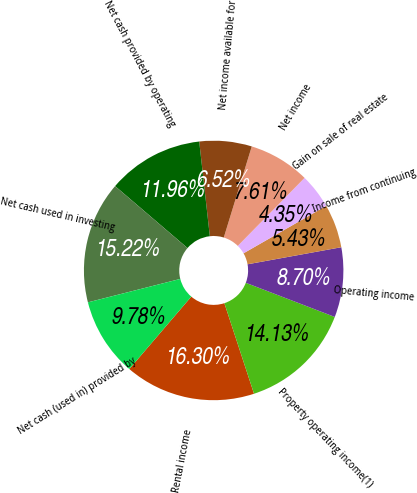Convert chart to OTSL. <chart><loc_0><loc_0><loc_500><loc_500><pie_chart><fcel>Rental income<fcel>Property operating income(1)<fcel>Operating income<fcel>Income from continuing<fcel>Gain on sale of real estate<fcel>Net income<fcel>Net income available for<fcel>Net cash provided by operating<fcel>Net cash used in investing<fcel>Net cash (used in) provided by<nl><fcel>16.3%<fcel>14.13%<fcel>8.7%<fcel>5.43%<fcel>4.35%<fcel>7.61%<fcel>6.52%<fcel>11.96%<fcel>15.22%<fcel>9.78%<nl></chart> 